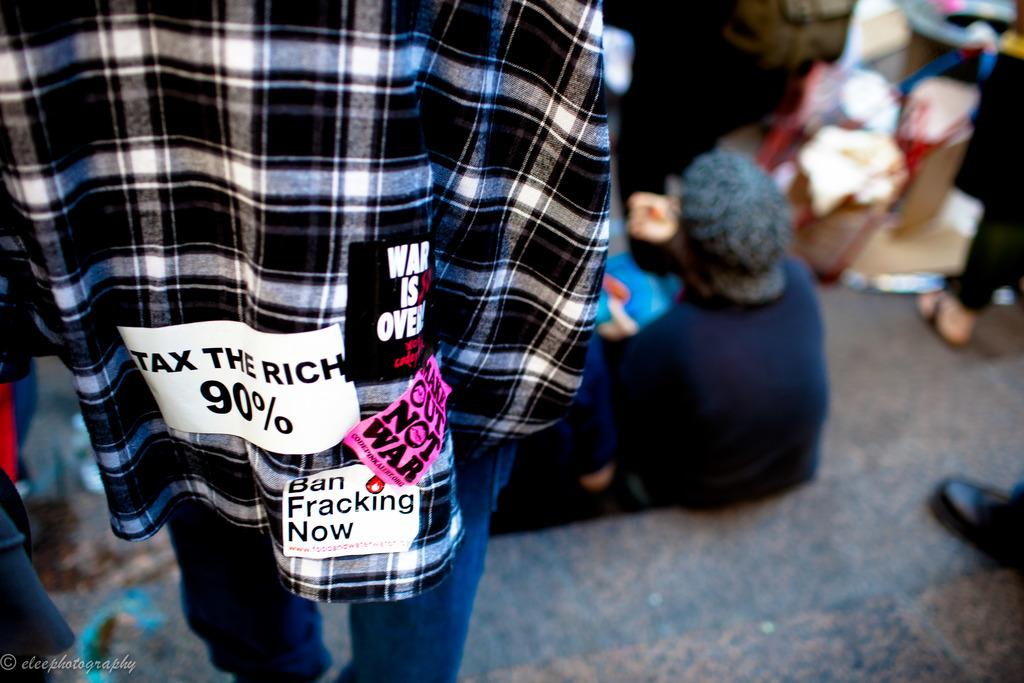How many people are in the image? There is a group of people in the image, but the exact number is not specified. What are the people in the image doing? Some people are seated, while others are standing. Is there any text or marking visible in the image? Yes, there is a watermark at the left bottom of the image. What type of mist can be seen in the image? There is no mist present in the image. What is the cause of the loss experienced by the people in the image? There is no indication of any loss experienced by the people in the image. 